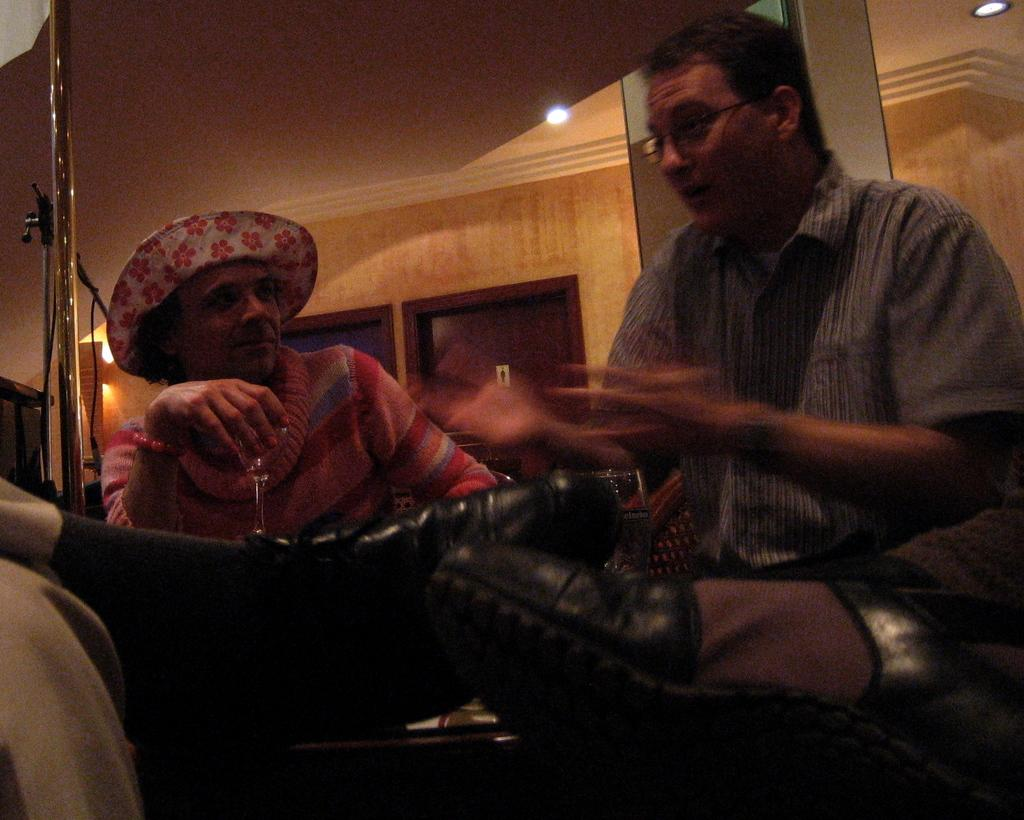How many people can be seen in the image? There are people in the image, but the exact number is not specified. What part of the people's bodies is visible in the image? The legs of two persons are visible in the image. What structures are present in the image? There is a pole, a stand, lights, a wall, windows, and a roof in the image. What month is it in the image? The month is not mentioned or depicted in the image. Can you describe the face of the person in the image? There is no face visible in the image; only the legs of two persons are visible. 